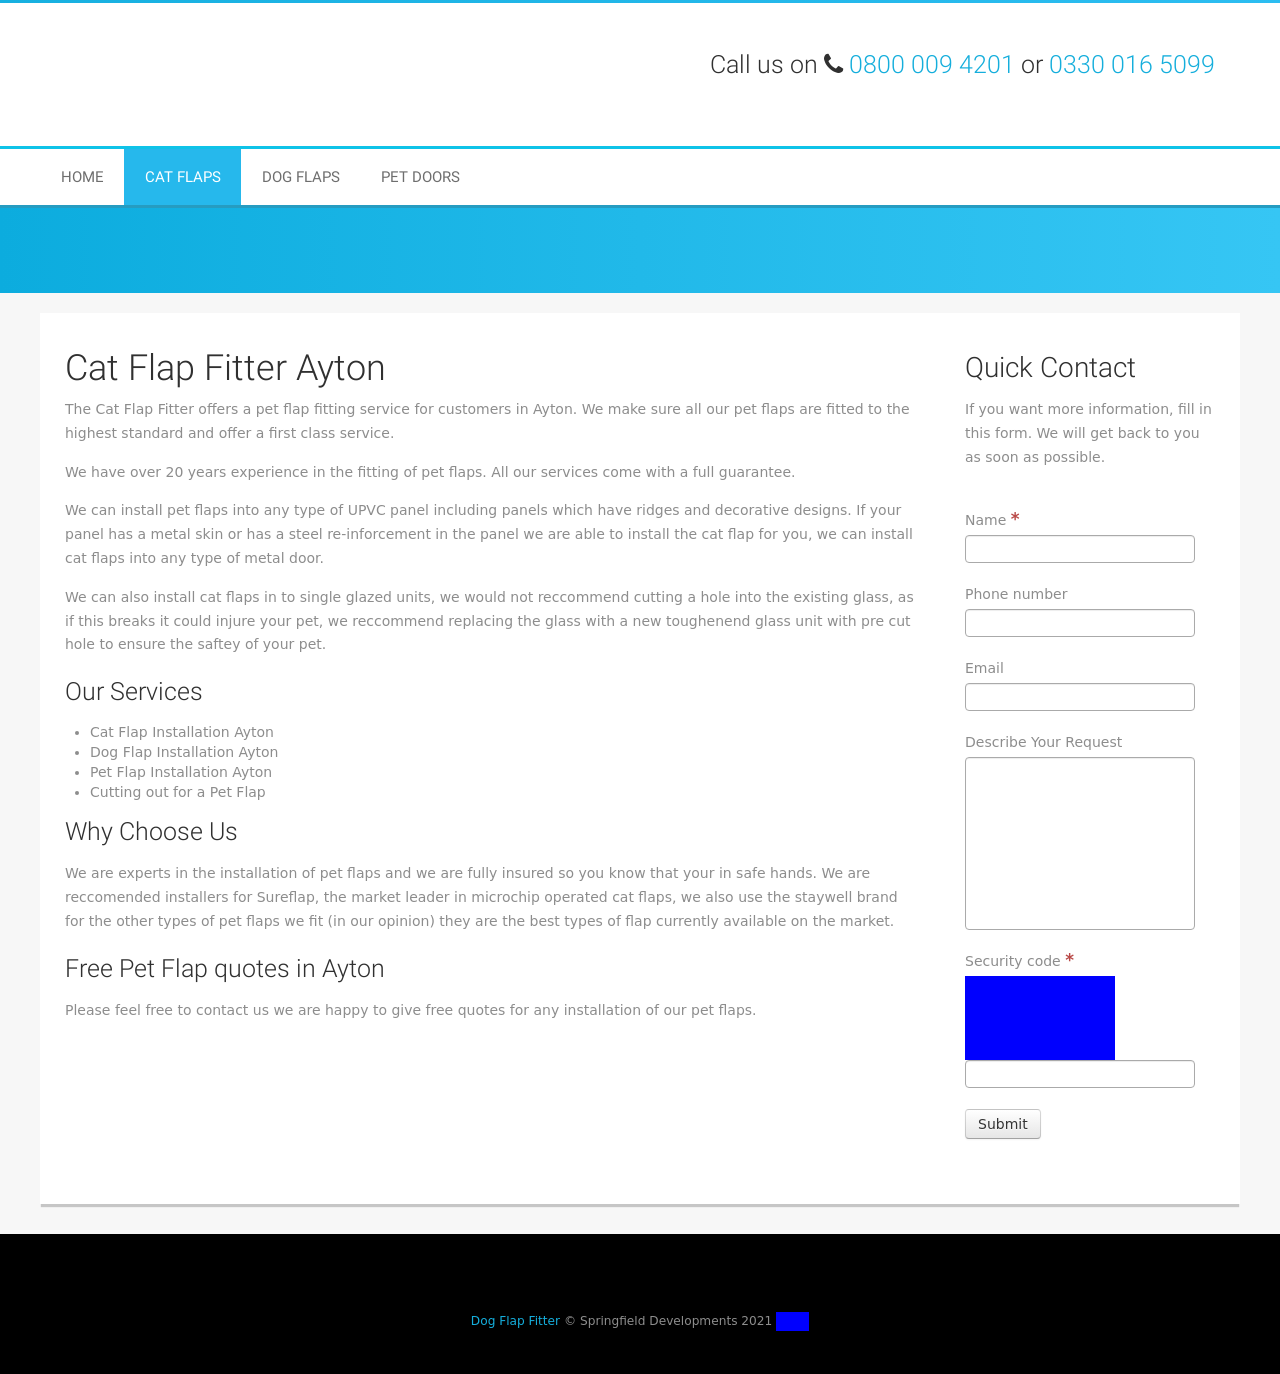Could you guide me through the process of developing this website with HTML? To develop a website similar to the ones shown in the image with HTML, you'd start by creating a basic HTML structure. Include elements like <!DOCTYPE html>, <html>, <head>, and <body>. Inside the <head>, include meta tags for responsiveness and SEO, and link your CSS for styling. In the body, structure your content using <header>, <nav> for the menu, <main> for your primary content like the services offered by the Cat Flap Fitter, and <footer> for additional company information. Use <div> tags to segment sections and grids, utilize <h1> to <h6> for headings, <p> for paragraphs, and <a> for links. For interactivity or more advanced behaviors, consider learning CSS for styles and JavaScript for functionality. 